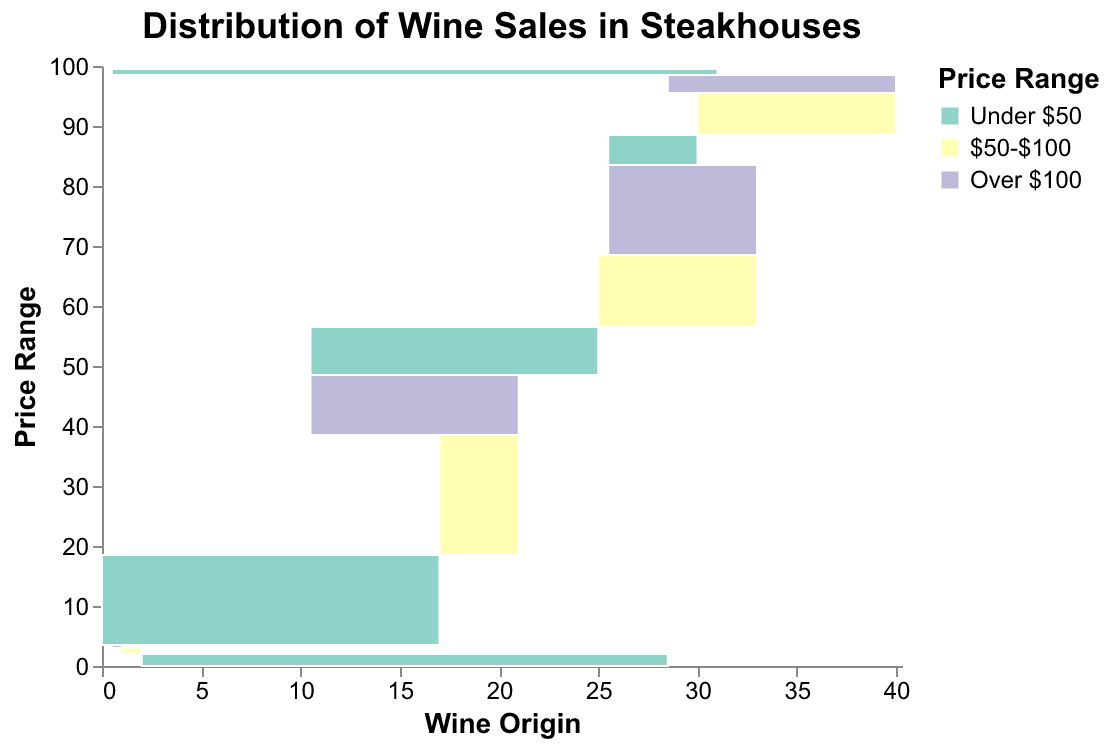What is the title of the figure? The title is displayed prominently at the top of the plot. It reads "Distribution of Wine Sales in Steakhouses".
Answer: Distribution of Wine Sales in Steakhouses Which wine origin has the highest sales percentage for the $50-$100 price range? Looking at the $50-$100 price range color in the mosaic plot, the largest area is associated with California.
Answer: California What are the price ranges represented in the figure? The color legend indicates three price ranges: "Under $50", "$50-$100", and "Over $100".
Answer: Under $50, $50-$100, Over $100 Compare the sales percentages of French wines in the "Under $50" and "Over $100" categories. Locate the sections for France in the "Under $50" and "Over $100" categories. France has an 8% sales percentage in "Under $50" and a 15% sales percentage in "Over $100".
Answer: 8% Under $50, 15% Over $100 Which wine origin has the smallest sales percentage for the "Over $100" price range? The "Over $100" price range is colored distinctively. The smallest segment is associated with Spain, with a 0.2% sales percentage.
Answer: Spain How do the wine sales percentages from Italy compare across all three price ranges? For Italy, identify the "Under $50" (5%), "$50-$100" (7%), and "Over $100" (3%) sections. Italy shows the highest sales percentage in the $50-$100 range and the lowest in the "Over $100" range.
Answer: 5% Under $50, 7% $50-$100, 3% Over $100 What wine origin has the overall highest sales percentage across all price ranges? Sum the sales percentages for each price range for each wine origin. California has a total of 45% across all price ranges, which is the highest.
Answer: California Among wines priced "Under $50", which origins have the closest sales percentages, and what are they? Comparing "Under $50" categories, Argentina (2%) and Spain (1%) have the closest percentages.
Answer: Argentina and Spain, 2% and 1% Which wine origin has the second highest sales percentage in the "Over $100" price range? In the "Over $100" range, the first highest for California (10%), the second highest is France (15%).
Answer: France How much greater is the sales percentage for California wines over $50-$100 compared to Italian wines in the same range? California in $50-$100 has 20%, Italy has 7%. The difference is 20% - 7% = 13%.
Answer: 13% 